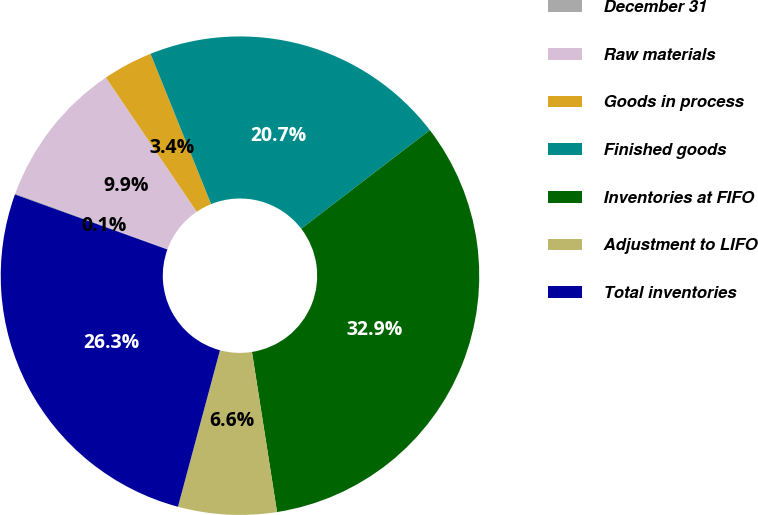Convert chart. <chart><loc_0><loc_0><loc_500><loc_500><pie_chart><fcel>December 31<fcel>Raw materials<fcel>Goods in process<fcel>Finished goods<fcel>Inventories at FIFO<fcel>Adjustment to LIFO<fcel>Total inventories<nl><fcel>0.08%<fcel>9.94%<fcel>3.37%<fcel>20.69%<fcel>32.94%<fcel>6.65%<fcel>26.34%<nl></chart> 